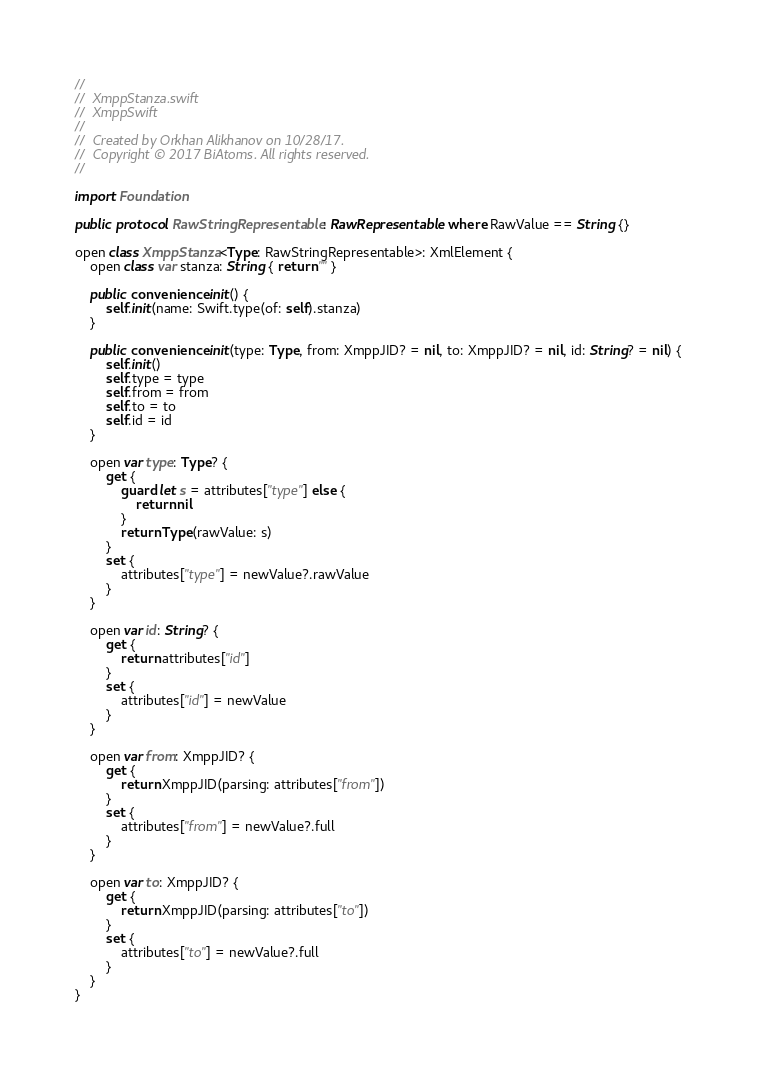Convert code to text. <code><loc_0><loc_0><loc_500><loc_500><_Swift_>//
//  XmppStanza.swift
//  XmppSwift
//
//  Created by Orkhan Alikhanov on 10/28/17.
//  Copyright © 2017 BiAtoms. All rights reserved.
//

import Foundation

public protocol RawStringRepresentable: RawRepresentable where RawValue == String {}

open class XmppStanza<Type: RawStringRepresentable>: XmlElement {
    open class var stanza: String { return "" }
    
    public convenience init() {
        self.init(name: Swift.type(of: self).stanza)
    }
    
    public convenience init(type: Type, from: XmppJID? = nil, to: XmppJID? = nil, id: String? = nil) {
        self.init()
        self.type = type
        self.from = from
        self.to = to
        self.id = id
    }
    
    open var type: Type? {
        get {
            guard let s = attributes["type"] else {
                return nil
            }
            return Type(rawValue: s)
        }
        set {
            attributes["type"] = newValue?.rawValue
        }
    }
    
    open var id: String? {
        get {
            return attributes["id"]
        }
        set {
            attributes["id"] = newValue
        }
    }
    
    open var from: XmppJID? {
        get {
            return XmppJID(parsing: attributes["from"])
        }
        set {
            attributes["from"] = newValue?.full
        }
    }
    
    open var to: XmppJID? {
        get {
            return XmppJID(parsing: attributes["to"])
        }
        set {
            attributes["to"] = newValue?.full
        }
    }
}
</code> 